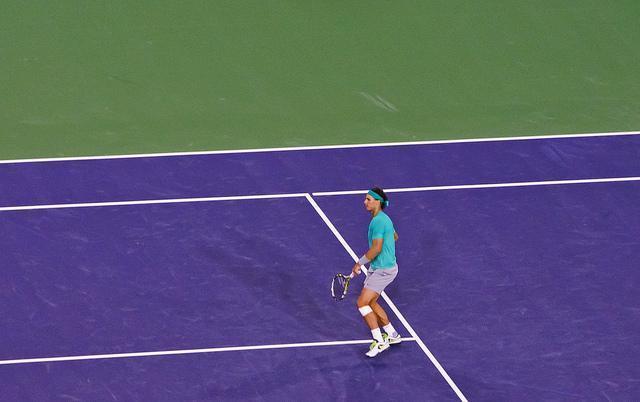How many sheep are in this picture?
Give a very brief answer. 0. 